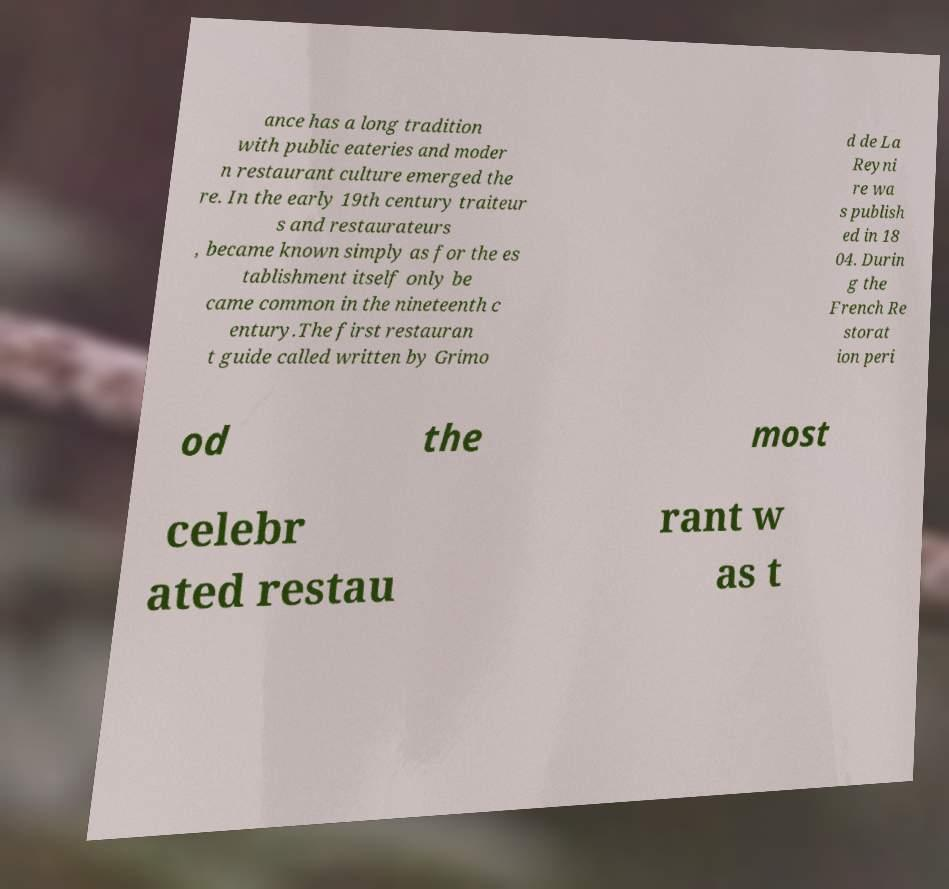Can you accurately transcribe the text from the provided image for me? ance has a long tradition with public eateries and moder n restaurant culture emerged the re. In the early 19th century traiteur s and restaurateurs , became known simply as for the es tablishment itself only be came common in the nineteenth c entury.The first restauran t guide called written by Grimo d de La Reyni re wa s publish ed in 18 04. Durin g the French Re storat ion peri od the most celebr ated restau rant w as t 